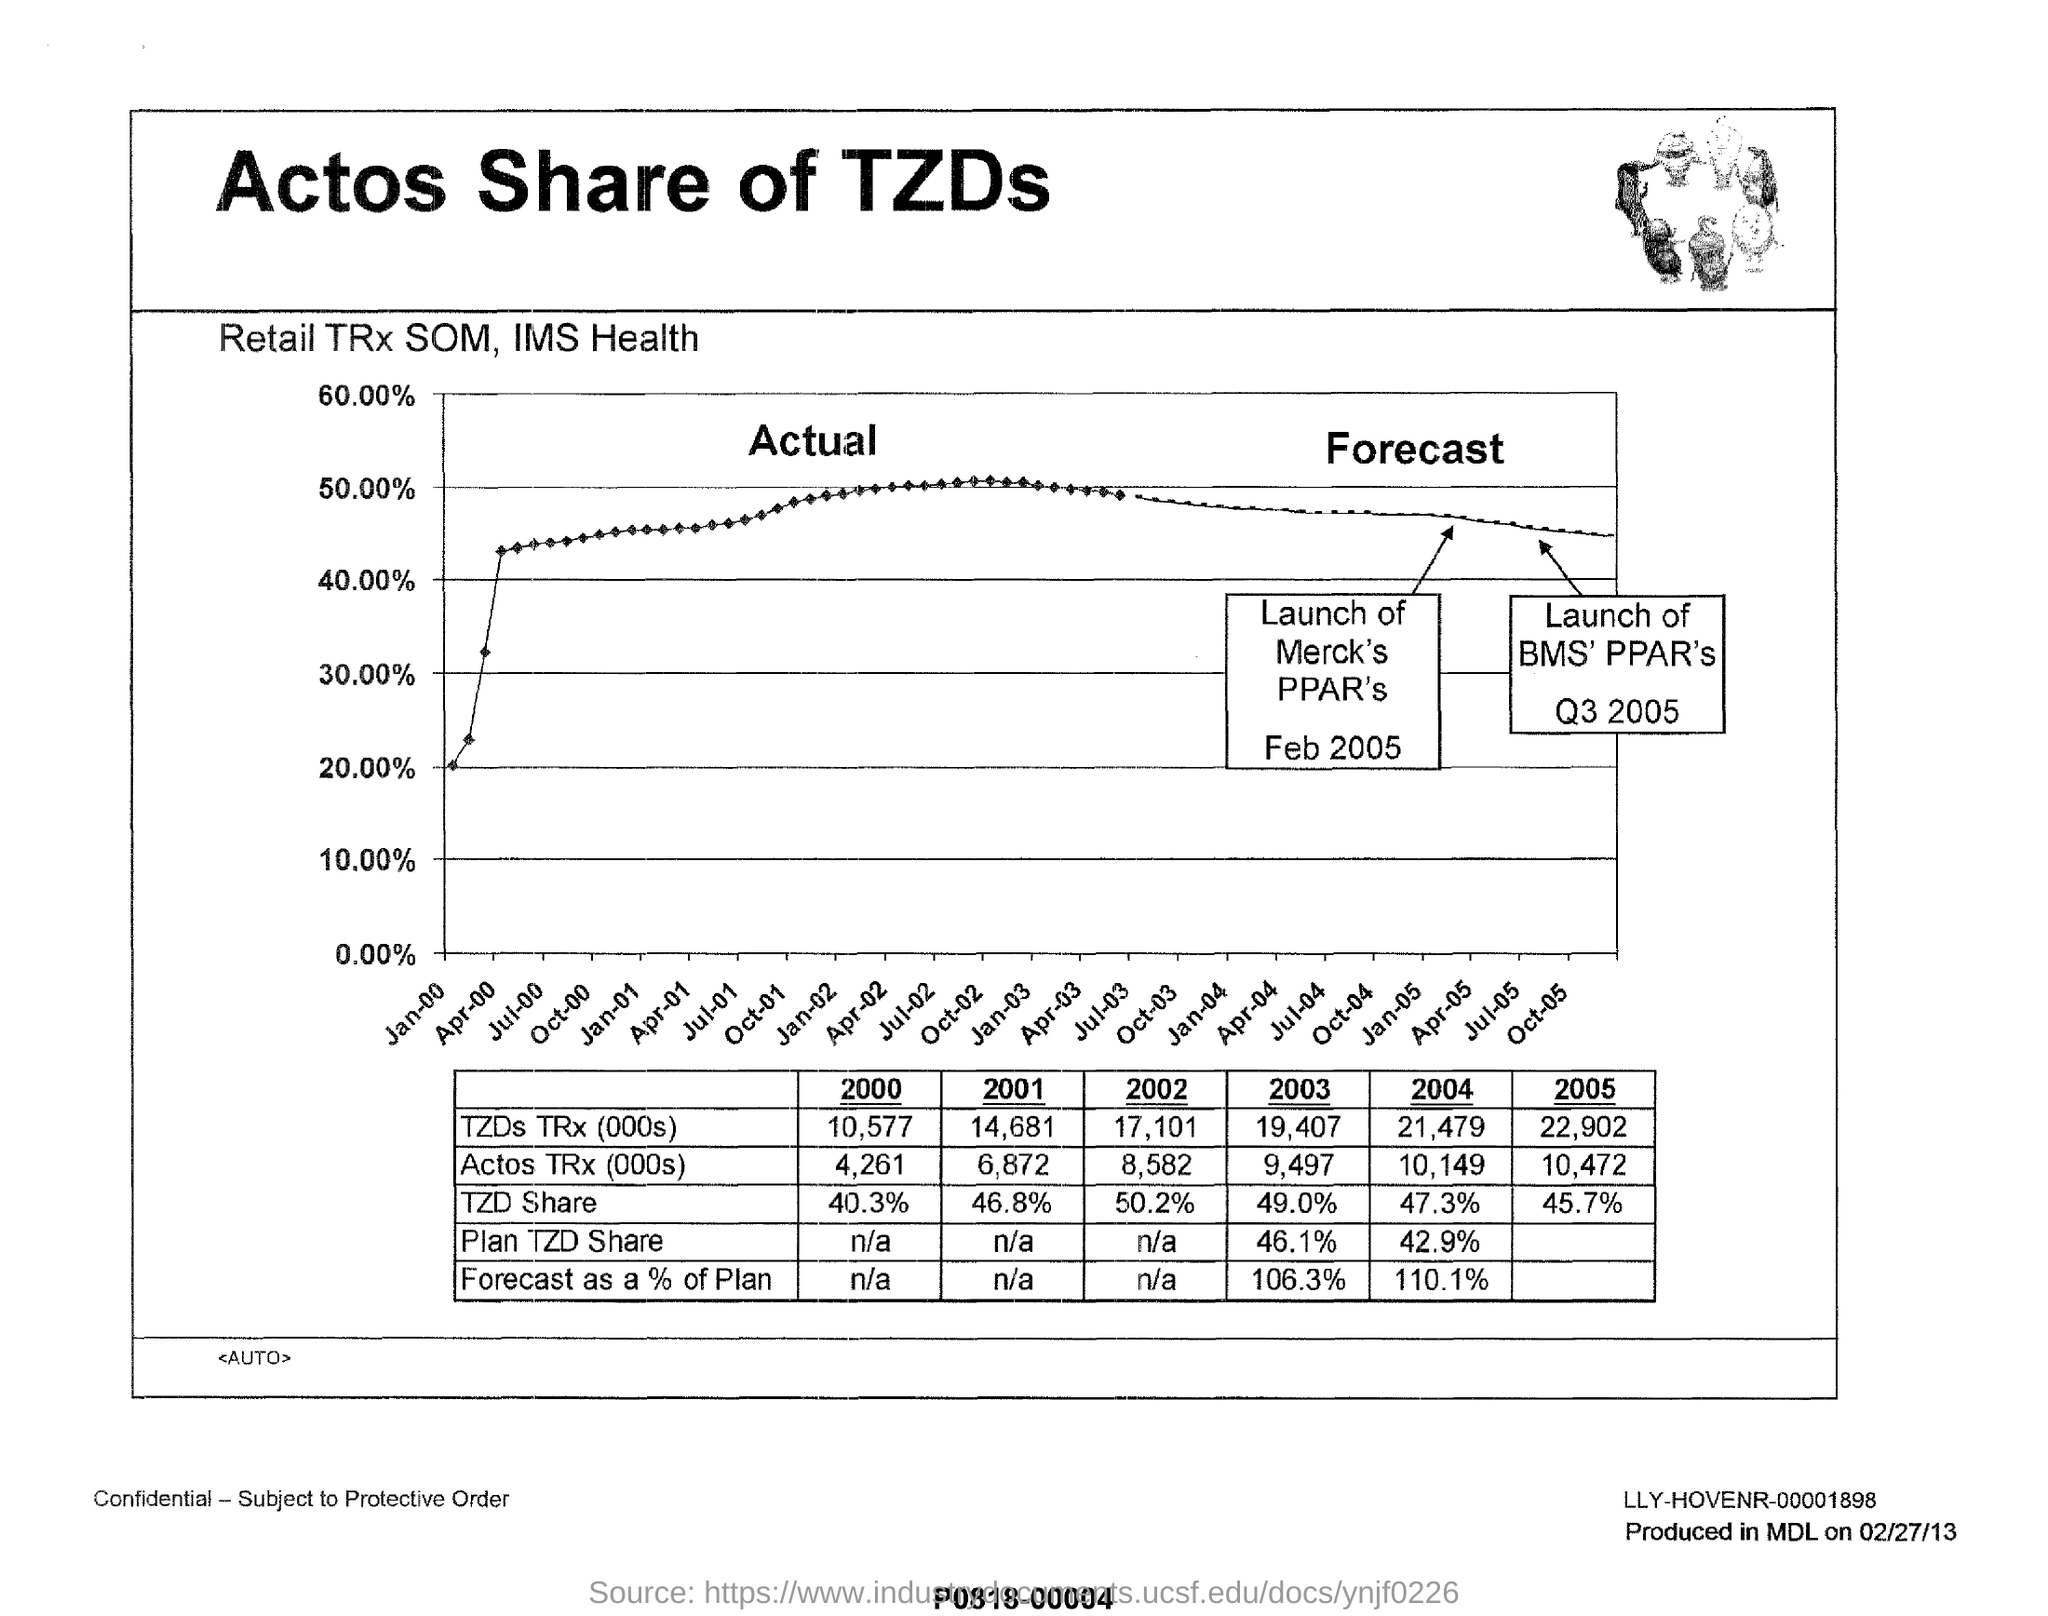What is the percentage of  tzd share in the year 2000 ?
Keep it short and to the point. 40.3%. What is actos trx (000s) in the year 2003 ?
Your answer should be very brief. 9,497. What is the percentage of plan tzd share in the year 2004 ?
Keep it short and to the point. 42.9%. In which month and the year the launch of merck's ppar's took place?
Offer a terse response. Feb 2005. What is the tzd's trx (000s) in the year 2005 ?
Provide a short and direct response. 22,902. 